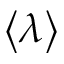Convert formula to latex. <formula><loc_0><loc_0><loc_500><loc_500>\left \langle \lambda \right \rangle</formula> 